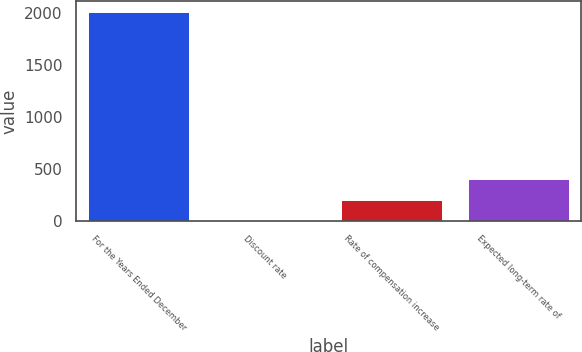Convert chart. <chart><loc_0><loc_0><loc_500><loc_500><bar_chart><fcel>For the Years Ended December<fcel>Discount rate<fcel>Rate of compensation increase<fcel>Expected long-term rate of<nl><fcel>2013<fcel>2.13<fcel>203.22<fcel>404.31<nl></chart> 